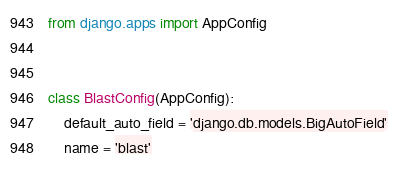Convert code to text. <code><loc_0><loc_0><loc_500><loc_500><_Python_>from django.apps import AppConfig


class BlastConfig(AppConfig):
    default_auto_field = 'django.db.models.BigAutoField'
    name = 'blast'
</code> 